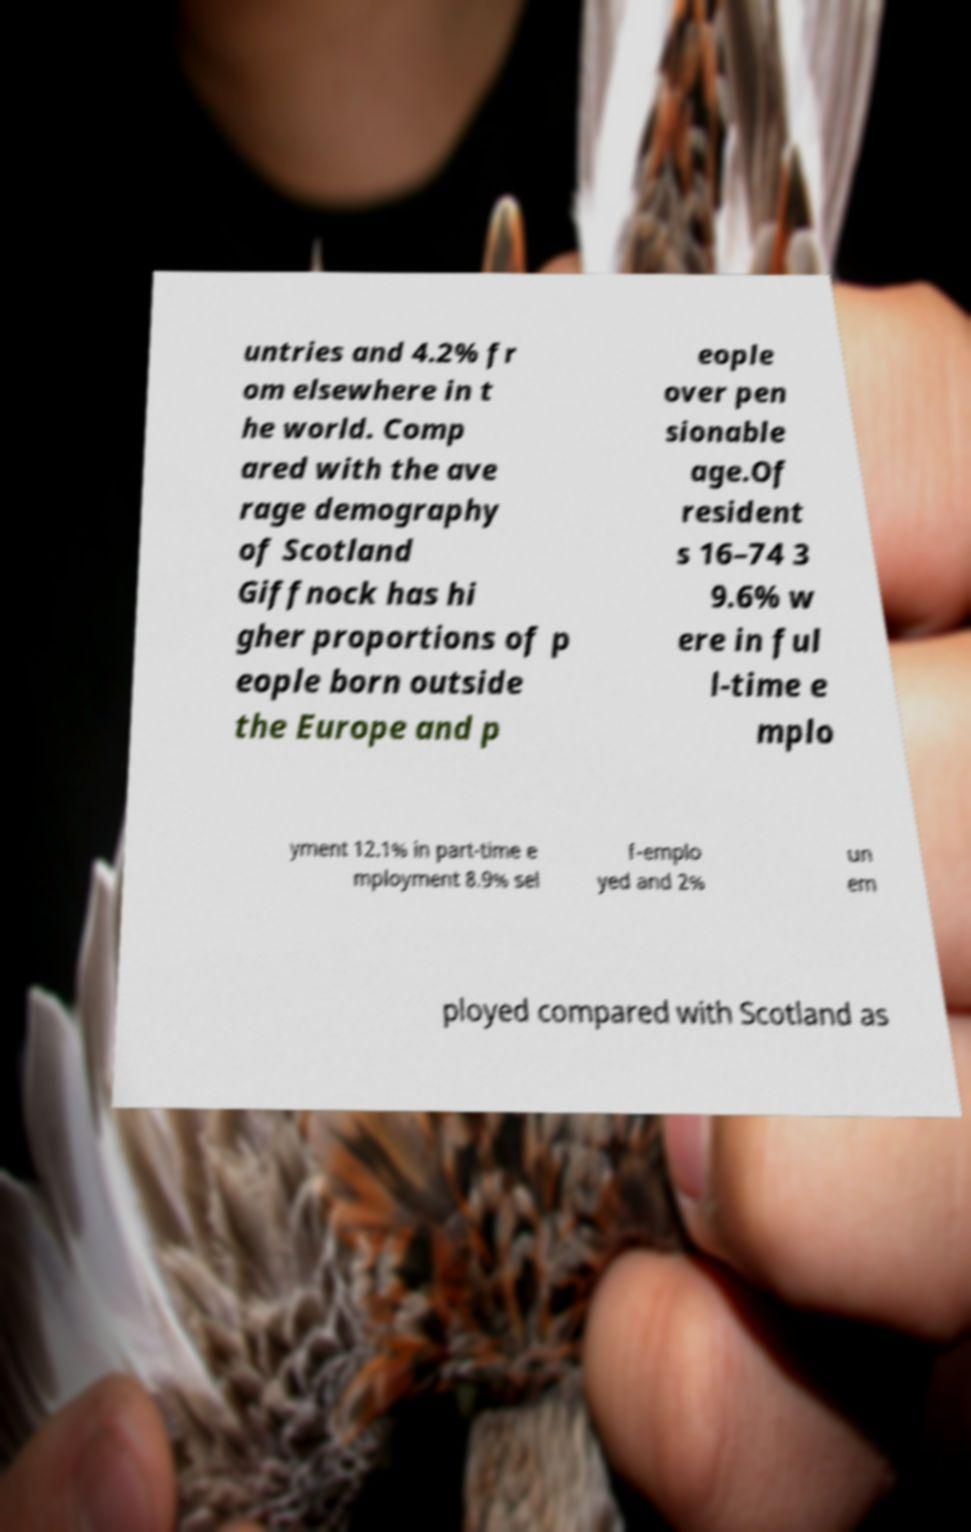Please read and relay the text visible in this image. What does it say? untries and 4.2% fr om elsewhere in t he world. Comp ared with the ave rage demography of Scotland Giffnock has hi gher proportions of p eople born outside the Europe and p eople over pen sionable age.Of resident s 16–74 3 9.6% w ere in ful l-time e mplo yment 12.1% in part-time e mployment 8.9% sel f-emplo yed and 2% un em ployed compared with Scotland as 